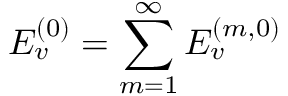<formula> <loc_0><loc_0><loc_500><loc_500>E _ { v } ^ { ( 0 ) } = \sum _ { m = 1 } ^ { \infty } E _ { v } ^ { ( m , 0 ) }</formula> 